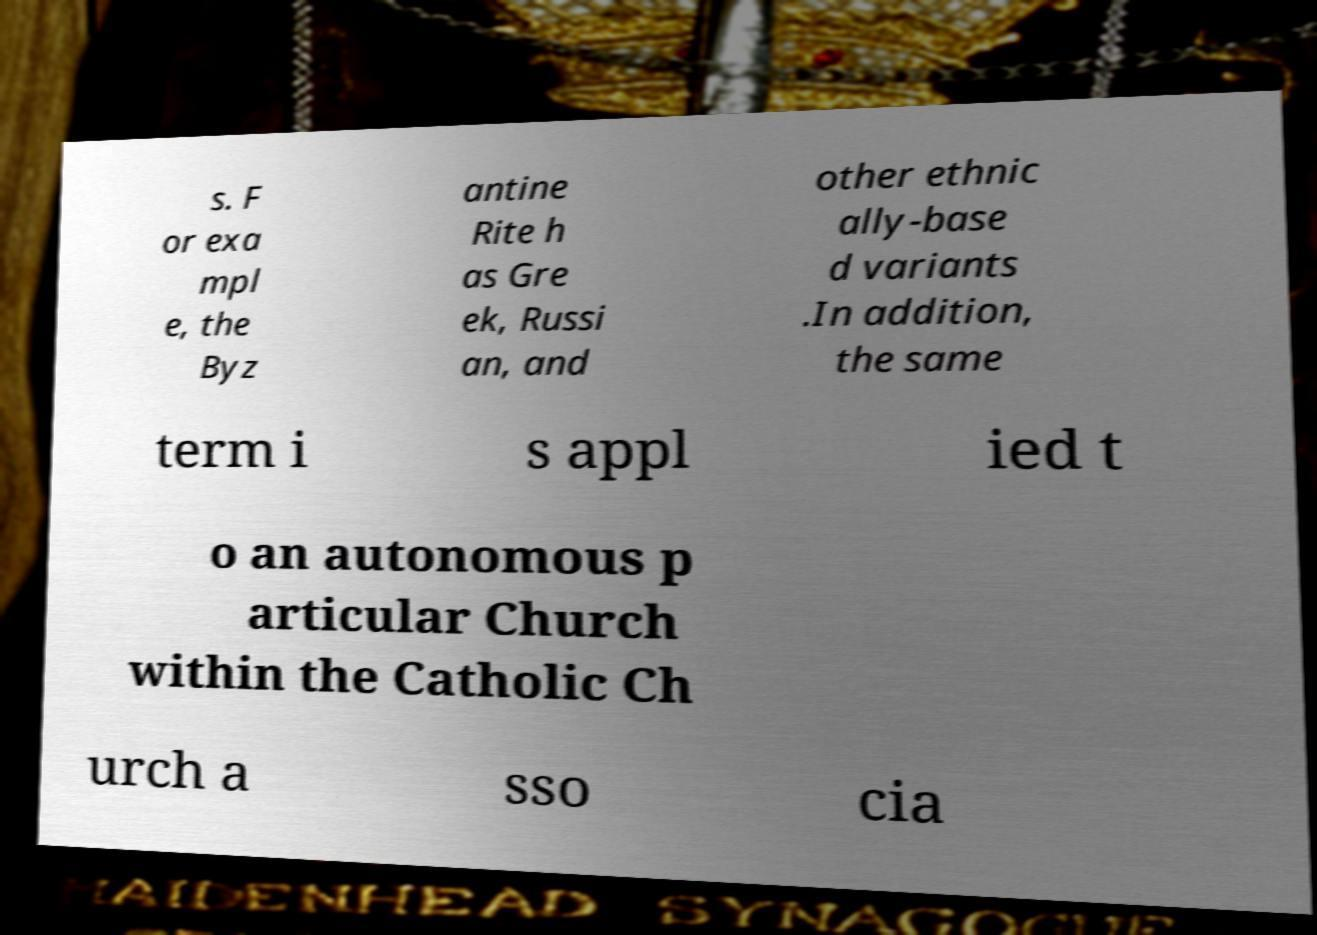Please identify and transcribe the text found in this image. s. F or exa mpl e, the Byz antine Rite h as Gre ek, Russi an, and other ethnic ally-base d variants .In addition, the same term i s appl ied t o an autonomous p articular Church within the Catholic Ch urch a sso cia 